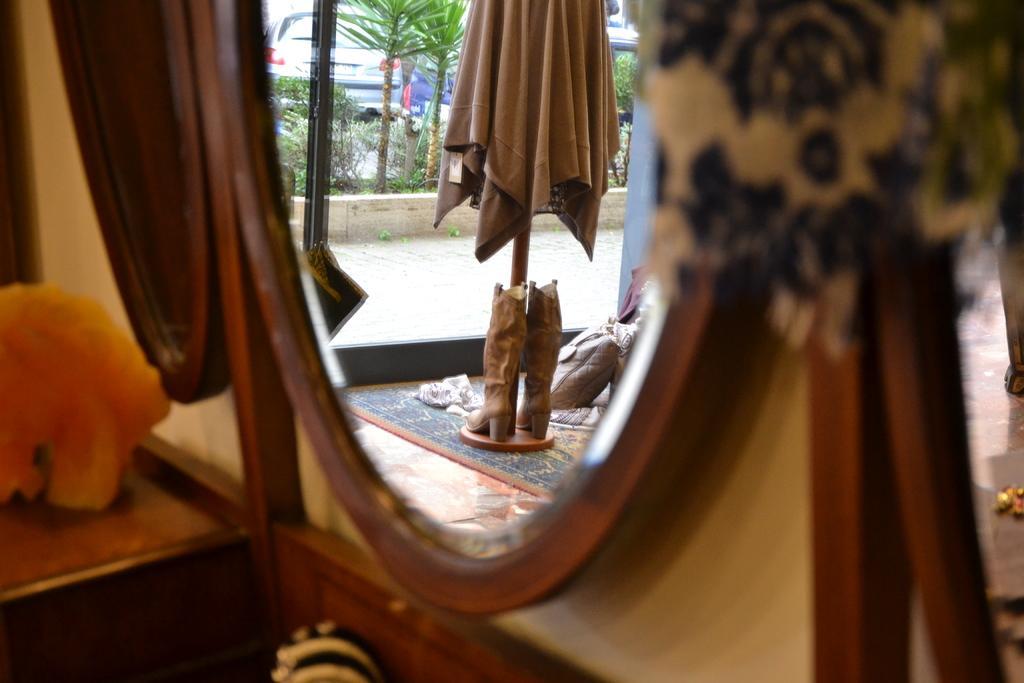Please provide a concise description of this image. In this image we can see a mirror. In which there is a reflection of a statue,trees,vehicles,road. To the left side of the image there is a wooden table. 